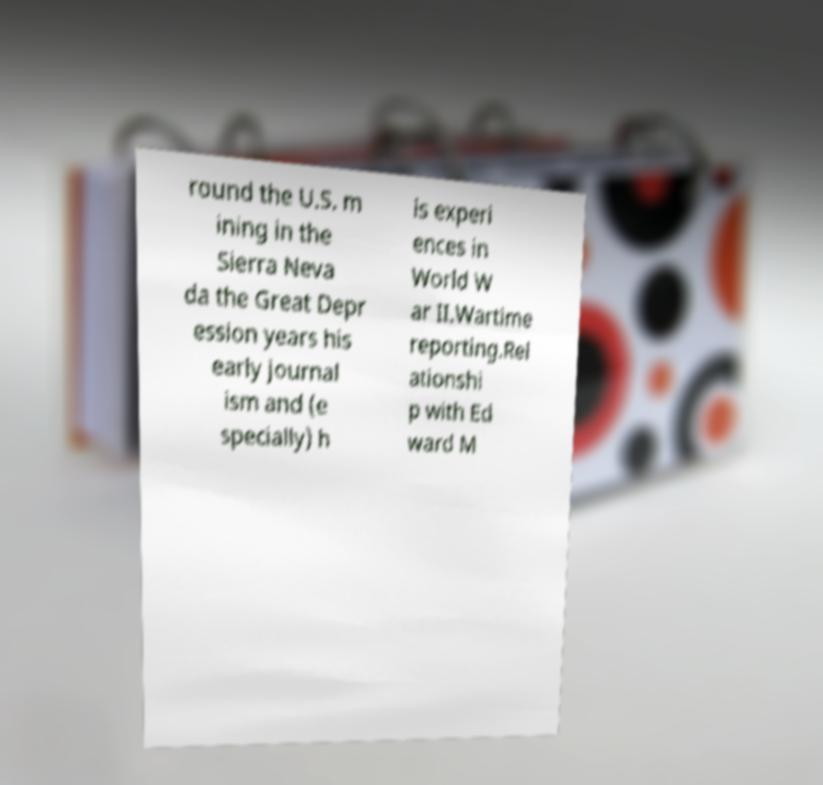There's text embedded in this image that I need extracted. Can you transcribe it verbatim? round the U.S. m ining in the Sierra Neva da the Great Depr ession years his early journal ism and (e specially) h is experi ences in World W ar II.Wartime reporting.Rel ationshi p with Ed ward M 